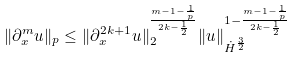Convert formula to latex. <formula><loc_0><loc_0><loc_500><loc_500>\| \partial _ { x } ^ { m } u \| _ { p } \leq \| \partial _ { x } ^ { 2 k + 1 } u \| _ { 2 } ^ { \frac { m - 1 - \frac { 1 } { p } } { 2 k - \frac { 1 } { 2 } } } \| u \| _ { \dot { H } ^ { \frac { 3 } { 2 } } } ^ { 1 - \frac { m - 1 - \frac { 1 } { p } } { 2 k - \frac { 1 } { 2 } } }</formula> 